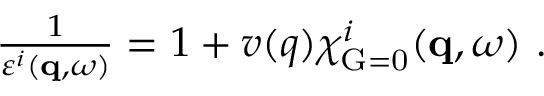Convert formula to latex. <formula><loc_0><loc_0><loc_500><loc_500>\begin{array} { r } { \frac { 1 } { \varepsilon ^ { i } ( q , \omega ) } = 1 + v ( q ) \chi _ { G = 0 } ^ { i } ( q , \omega ) \ . } \end{array}</formula> 